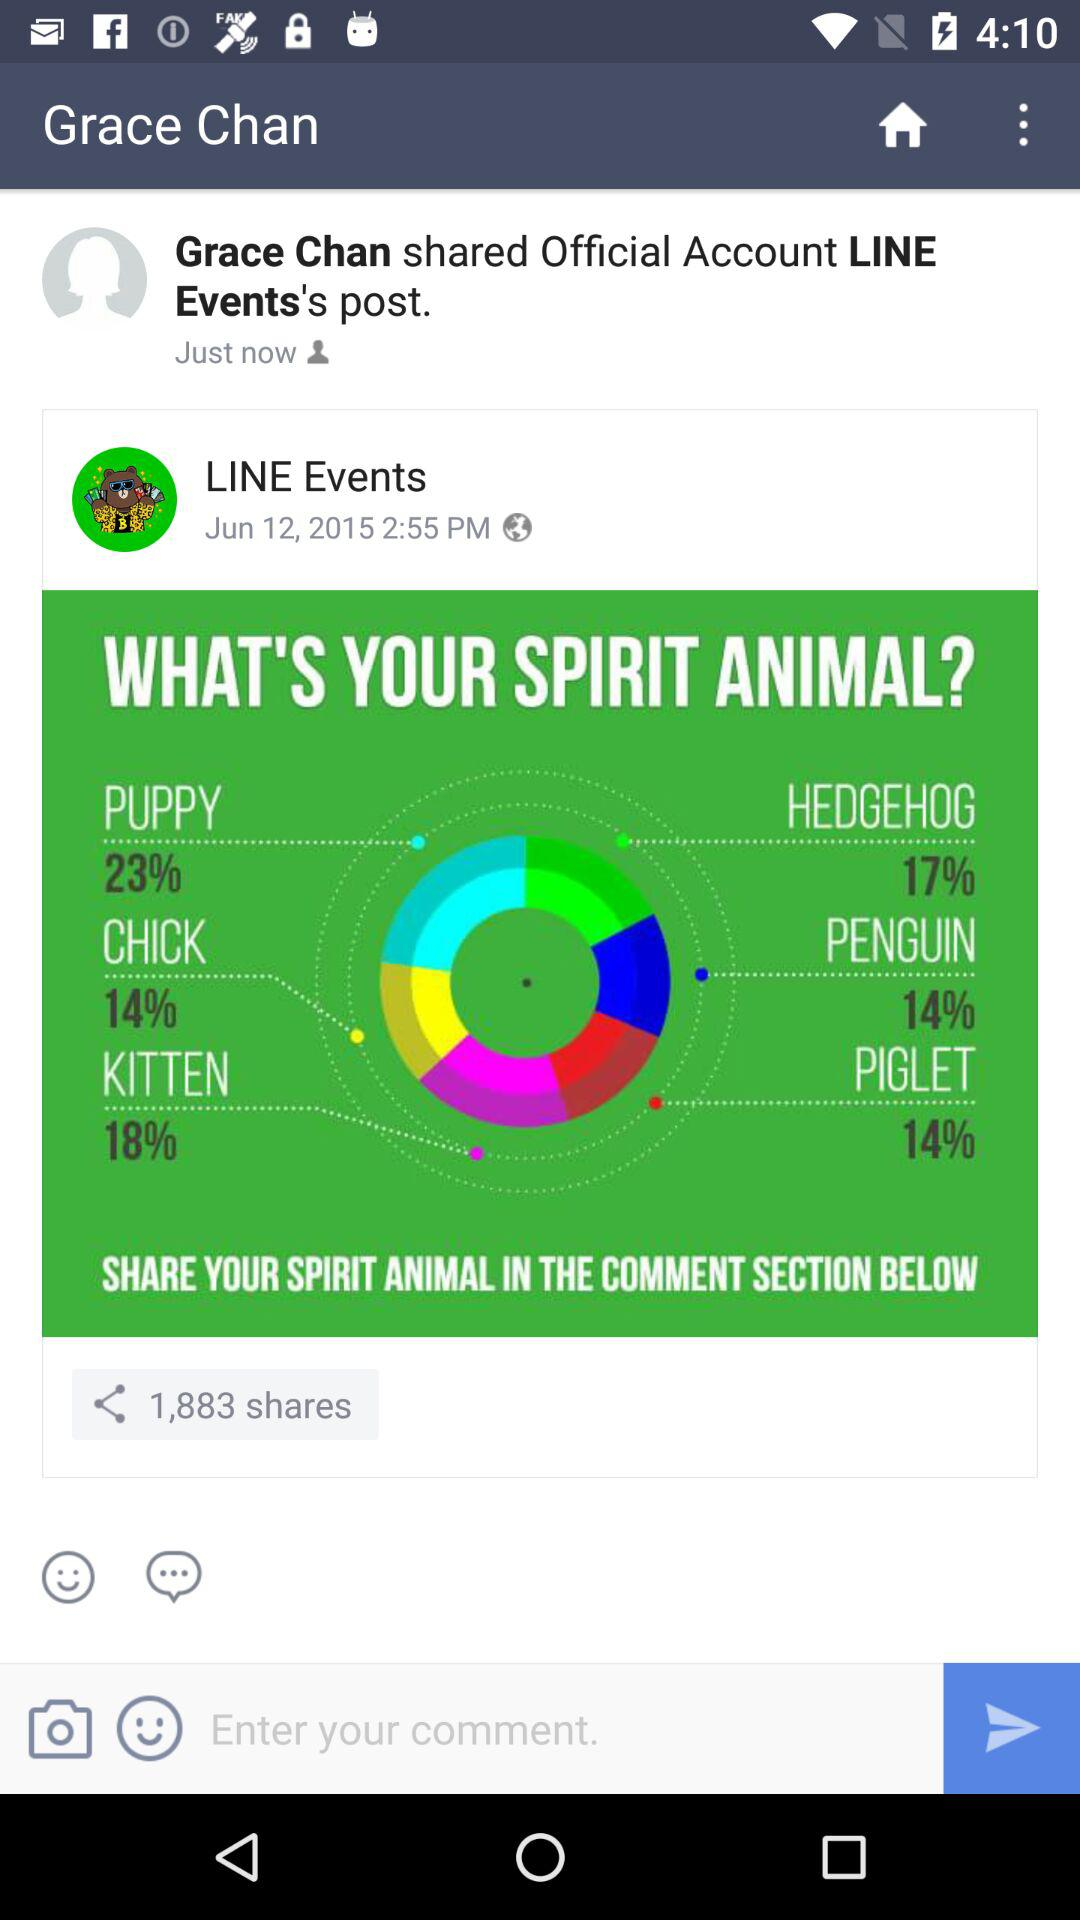At what time did Grace Chan share the official account "LINE Events" post? Grace Chan shared the post just now. 